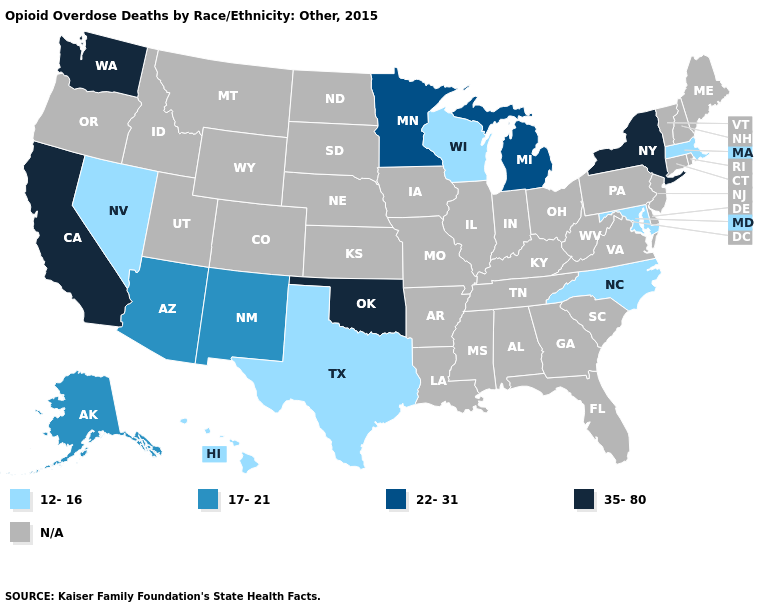Which states have the highest value in the USA?
Short answer required. California, New York, Oklahoma, Washington. Name the states that have a value in the range 35-80?
Be succinct. California, New York, Oklahoma, Washington. Does Washington have the highest value in the USA?
Short answer required. Yes. Name the states that have a value in the range 35-80?
Answer briefly. California, New York, Oklahoma, Washington. Which states hav the highest value in the MidWest?
Keep it brief. Michigan, Minnesota. How many symbols are there in the legend?
Keep it brief. 5. Does the map have missing data?
Quick response, please. Yes. Does the map have missing data?
Answer briefly. Yes. Which states have the lowest value in the USA?
Answer briefly. Hawaii, Maryland, Massachusetts, Nevada, North Carolina, Texas, Wisconsin. Does the first symbol in the legend represent the smallest category?
Quick response, please. Yes. Name the states that have a value in the range 35-80?
Answer briefly. California, New York, Oklahoma, Washington. What is the value of Illinois?
Give a very brief answer. N/A. What is the value of South Dakota?
Keep it brief. N/A. Does North Carolina have the lowest value in the South?
Quick response, please. Yes. 